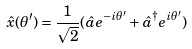Convert formula to latex. <formula><loc_0><loc_0><loc_500><loc_500>\hat { x } ( \theta ^ { \prime } ) = \frac { 1 } { \sqrt { 2 } } ( \hat { a } e ^ { - i \theta ^ { \prime } } + \hat { a } ^ { \dagger } e ^ { i \theta ^ { \prime } } )</formula> 